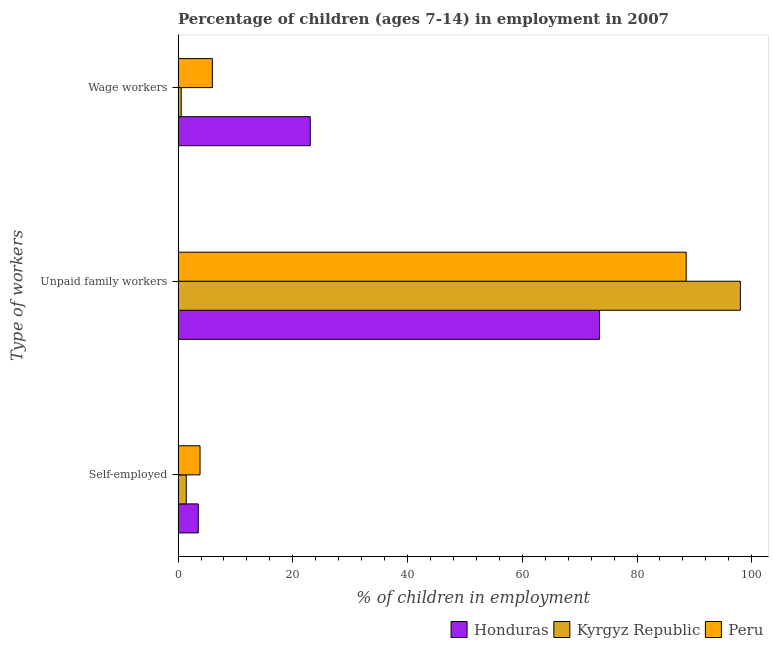How many different coloured bars are there?
Offer a very short reply. 3. How many groups of bars are there?
Your response must be concise. 3. Are the number of bars per tick equal to the number of legend labels?
Make the answer very short. Yes. Are the number of bars on each tick of the Y-axis equal?
Ensure brevity in your answer.  Yes. How many bars are there on the 1st tick from the bottom?
Your answer should be compact. 3. What is the label of the 1st group of bars from the top?
Make the answer very short. Wage workers. What is the percentage of children employed as wage workers in Kyrgyz Republic?
Keep it short and to the point. 0.55. Across all countries, what is the maximum percentage of children employed as wage workers?
Ensure brevity in your answer.  23.04. Across all countries, what is the minimum percentage of self employed children?
Make the answer very short. 1.43. In which country was the percentage of children employed as unpaid family workers minimum?
Your answer should be very brief. Honduras. What is the total percentage of self employed children in the graph?
Ensure brevity in your answer.  8.78. What is the difference between the percentage of self employed children in Kyrgyz Republic and that in Peru?
Give a very brief answer. -2.4. What is the difference between the percentage of self employed children in Peru and the percentage of children employed as unpaid family workers in Honduras?
Give a very brief answer. -69.62. What is the average percentage of children employed as wage workers per country?
Give a very brief answer. 9.86. What is the difference between the percentage of self employed children and percentage of children employed as unpaid family workers in Kyrgyz Republic?
Offer a terse response. -96.59. In how many countries, is the percentage of self employed children greater than 84 %?
Provide a succinct answer. 0. What is the ratio of the percentage of children employed as unpaid family workers in Honduras to that in Kyrgyz Republic?
Your answer should be compact. 0.75. Is the percentage of self employed children in Peru less than that in Kyrgyz Republic?
Offer a very short reply. No. What is the difference between the highest and the second highest percentage of self employed children?
Ensure brevity in your answer.  0.31. What is the difference between the highest and the lowest percentage of children employed as unpaid family workers?
Your answer should be compact. 24.57. In how many countries, is the percentage of self employed children greater than the average percentage of self employed children taken over all countries?
Ensure brevity in your answer.  2. What does the 3rd bar from the top in Self-employed represents?
Offer a terse response. Honduras. What does the 1st bar from the bottom in Wage workers represents?
Ensure brevity in your answer.  Honduras. Is it the case that in every country, the sum of the percentage of self employed children and percentage of children employed as unpaid family workers is greater than the percentage of children employed as wage workers?
Keep it short and to the point. Yes. Are all the bars in the graph horizontal?
Offer a very short reply. Yes. Does the graph contain any zero values?
Provide a short and direct response. No. Where does the legend appear in the graph?
Provide a short and direct response. Bottom right. What is the title of the graph?
Ensure brevity in your answer.  Percentage of children (ages 7-14) in employment in 2007. Does "Marshall Islands" appear as one of the legend labels in the graph?
Your answer should be very brief. No. What is the label or title of the X-axis?
Ensure brevity in your answer.  % of children in employment. What is the label or title of the Y-axis?
Make the answer very short. Type of workers. What is the % of children in employment of Honduras in Self-employed?
Provide a short and direct response. 3.52. What is the % of children in employment of Kyrgyz Republic in Self-employed?
Provide a succinct answer. 1.43. What is the % of children in employment in Peru in Self-employed?
Make the answer very short. 3.83. What is the % of children in employment in Honduras in Unpaid family workers?
Keep it short and to the point. 73.45. What is the % of children in employment of Kyrgyz Republic in Unpaid family workers?
Provide a short and direct response. 98.02. What is the % of children in employment in Peru in Unpaid family workers?
Offer a very short reply. 88.57. What is the % of children in employment in Honduras in Wage workers?
Offer a very short reply. 23.04. What is the % of children in employment of Kyrgyz Republic in Wage workers?
Your response must be concise. 0.55. What is the % of children in employment in Peru in Wage workers?
Ensure brevity in your answer.  5.98. Across all Type of workers, what is the maximum % of children in employment in Honduras?
Ensure brevity in your answer.  73.45. Across all Type of workers, what is the maximum % of children in employment of Kyrgyz Republic?
Make the answer very short. 98.02. Across all Type of workers, what is the maximum % of children in employment in Peru?
Offer a terse response. 88.57. Across all Type of workers, what is the minimum % of children in employment in Honduras?
Your answer should be very brief. 3.52. Across all Type of workers, what is the minimum % of children in employment of Kyrgyz Republic?
Keep it short and to the point. 0.55. Across all Type of workers, what is the minimum % of children in employment in Peru?
Keep it short and to the point. 3.83. What is the total % of children in employment of Honduras in the graph?
Your answer should be compact. 100.01. What is the total % of children in employment in Kyrgyz Republic in the graph?
Ensure brevity in your answer.  100. What is the total % of children in employment of Peru in the graph?
Your answer should be compact. 98.38. What is the difference between the % of children in employment in Honduras in Self-employed and that in Unpaid family workers?
Ensure brevity in your answer.  -69.93. What is the difference between the % of children in employment in Kyrgyz Republic in Self-employed and that in Unpaid family workers?
Make the answer very short. -96.59. What is the difference between the % of children in employment of Peru in Self-employed and that in Unpaid family workers?
Keep it short and to the point. -84.74. What is the difference between the % of children in employment in Honduras in Self-employed and that in Wage workers?
Provide a succinct answer. -19.52. What is the difference between the % of children in employment in Kyrgyz Republic in Self-employed and that in Wage workers?
Your answer should be compact. 0.88. What is the difference between the % of children in employment of Peru in Self-employed and that in Wage workers?
Offer a terse response. -2.15. What is the difference between the % of children in employment of Honduras in Unpaid family workers and that in Wage workers?
Make the answer very short. 50.41. What is the difference between the % of children in employment of Kyrgyz Republic in Unpaid family workers and that in Wage workers?
Your answer should be compact. 97.47. What is the difference between the % of children in employment of Peru in Unpaid family workers and that in Wage workers?
Give a very brief answer. 82.59. What is the difference between the % of children in employment of Honduras in Self-employed and the % of children in employment of Kyrgyz Republic in Unpaid family workers?
Offer a terse response. -94.5. What is the difference between the % of children in employment of Honduras in Self-employed and the % of children in employment of Peru in Unpaid family workers?
Your answer should be very brief. -85.05. What is the difference between the % of children in employment of Kyrgyz Republic in Self-employed and the % of children in employment of Peru in Unpaid family workers?
Offer a very short reply. -87.14. What is the difference between the % of children in employment of Honduras in Self-employed and the % of children in employment of Kyrgyz Republic in Wage workers?
Offer a terse response. 2.97. What is the difference between the % of children in employment of Honduras in Self-employed and the % of children in employment of Peru in Wage workers?
Make the answer very short. -2.46. What is the difference between the % of children in employment of Kyrgyz Republic in Self-employed and the % of children in employment of Peru in Wage workers?
Give a very brief answer. -4.55. What is the difference between the % of children in employment in Honduras in Unpaid family workers and the % of children in employment in Kyrgyz Republic in Wage workers?
Make the answer very short. 72.9. What is the difference between the % of children in employment of Honduras in Unpaid family workers and the % of children in employment of Peru in Wage workers?
Your answer should be compact. 67.47. What is the difference between the % of children in employment of Kyrgyz Republic in Unpaid family workers and the % of children in employment of Peru in Wage workers?
Your answer should be compact. 92.04. What is the average % of children in employment in Honduras per Type of workers?
Keep it short and to the point. 33.34. What is the average % of children in employment of Kyrgyz Republic per Type of workers?
Offer a very short reply. 33.33. What is the average % of children in employment in Peru per Type of workers?
Make the answer very short. 32.79. What is the difference between the % of children in employment of Honduras and % of children in employment of Kyrgyz Republic in Self-employed?
Your answer should be very brief. 2.09. What is the difference between the % of children in employment in Honduras and % of children in employment in Peru in Self-employed?
Provide a succinct answer. -0.31. What is the difference between the % of children in employment in Kyrgyz Republic and % of children in employment in Peru in Self-employed?
Make the answer very short. -2.4. What is the difference between the % of children in employment of Honduras and % of children in employment of Kyrgyz Republic in Unpaid family workers?
Provide a short and direct response. -24.57. What is the difference between the % of children in employment in Honduras and % of children in employment in Peru in Unpaid family workers?
Keep it short and to the point. -15.12. What is the difference between the % of children in employment in Kyrgyz Republic and % of children in employment in Peru in Unpaid family workers?
Make the answer very short. 9.45. What is the difference between the % of children in employment in Honduras and % of children in employment in Kyrgyz Republic in Wage workers?
Provide a short and direct response. 22.49. What is the difference between the % of children in employment in Honduras and % of children in employment in Peru in Wage workers?
Make the answer very short. 17.06. What is the difference between the % of children in employment in Kyrgyz Republic and % of children in employment in Peru in Wage workers?
Offer a terse response. -5.43. What is the ratio of the % of children in employment in Honduras in Self-employed to that in Unpaid family workers?
Give a very brief answer. 0.05. What is the ratio of the % of children in employment of Kyrgyz Republic in Self-employed to that in Unpaid family workers?
Provide a succinct answer. 0.01. What is the ratio of the % of children in employment in Peru in Self-employed to that in Unpaid family workers?
Offer a terse response. 0.04. What is the ratio of the % of children in employment in Honduras in Self-employed to that in Wage workers?
Your answer should be compact. 0.15. What is the ratio of the % of children in employment in Peru in Self-employed to that in Wage workers?
Provide a succinct answer. 0.64. What is the ratio of the % of children in employment in Honduras in Unpaid family workers to that in Wage workers?
Provide a succinct answer. 3.19. What is the ratio of the % of children in employment of Kyrgyz Republic in Unpaid family workers to that in Wage workers?
Provide a succinct answer. 178.22. What is the ratio of the % of children in employment in Peru in Unpaid family workers to that in Wage workers?
Your answer should be compact. 14.81. What is the difference between the highest and the second highest % of children in employment of Honduras?
Provide a succinct answer. 50.41. What is the difference between the highest and the second highest % of children in employment of Kyrgyz Republic?
Offer a very short reply. 96.59. What is the difference between the highest and the second highest % of children in employment of Peru?
Your response must be concise. 82.59. What is the difference between the highest and the lowest % of children in employment in Honduras?
Keep it short and to the point. 69.93. What is the difference between the highest and the lowest % of children in employment in Kyrgyz Republic?
Your response must be concise. 97.47. What is the difference between the highest and the lowest % of children in employment of Peru?
Your answer should be very brief. 84.74. 